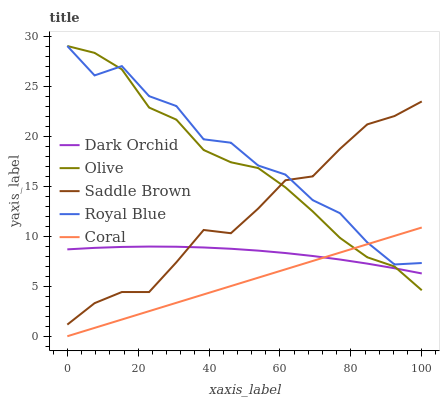Does Royal Blue have the minimum area under the curve?
Answer yes or no. No. Does Coral have the maximum area under the curve?
Answer yes or no. No. Is Royal Blue the smoothest?
Answer yes or no. No. Is Coral the roughest?
Answer yes or no. No. Does Royal Blue have the lowest value?
Answer yes or no. No. Does Coral have the highest value?
Answer yes or no. No. Is Dark Orchid less than Royal Blue?
Answer yes or no. Yes. Is Saddle Brown greater than Coral?
Answer yes or no. Yes. Does Dark Orchid intersect Royal Blue?
Answer yes or no. No. 